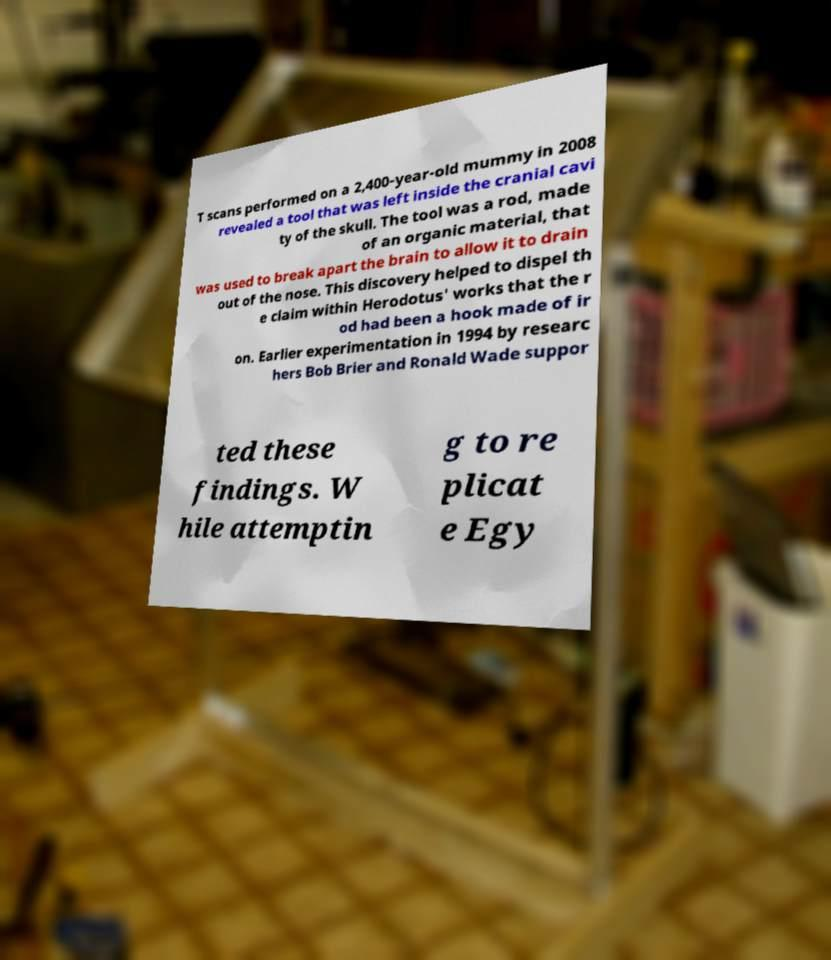For documentation purposes, I need the text within this image transcribed. Could you provide that? T scans performed on a 2,400-year-old mummy in 2008 revealed a tool that was left inside the cranial cavi ty of the skull. The tool was a rod, made of an organic material, that was used to break apart the brain to allow it to drain out of the nose. This discovery helped to dispel th e claim within Herodotus' works that the r od had been a hook made of ir on. Earlier experimentation in 1994 by researc hers Bob Brier and Ronald Wade suppor ted these findings. W hile attemptin g to re plicat e Egy 